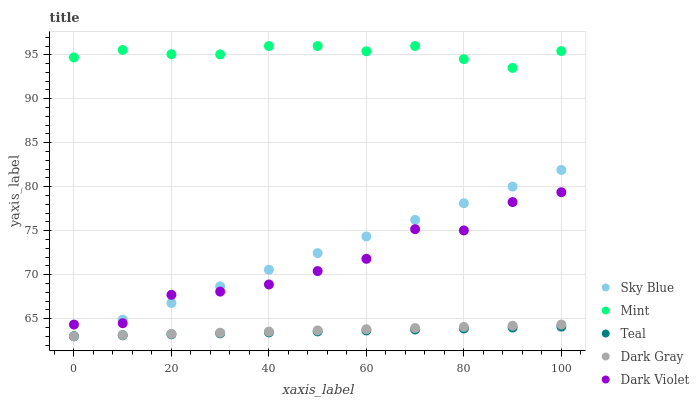Does Teal have the minimum area under the curve?
Answer yes or no. Yes. Does Mint have the maximum area under the curve?
Answer yes or no. Yes. Does Sky Blue have the minimum area under the curve?
Answer yes or no. No. Does Sky Blue have the maximum area under the curve?
Answer yes or no. No. Is Sky Blue the smoothest?
Answer yes or no. Yes. Is Dark Violet the roughest?
Answer yes or no. Yes. Is Mint the smoothest?
Answer yes or no. No. Is Mint the roughest?
Answer yes or no. No. Does Dark Gray have the lowest value?
Answer yes or no. Yes. Does Mint have the lowest value?
Answer yes or no. No. Does Mint have the highest value?
Answer yes or no. Yes. Does Sky Blue have the highest value?
Answer yes or no. No. Is Sky Blue less than Mint?
Answer yes or no. Yes. Is Mint greater than Dark Violet?
Answer yes or no. Yes. Does Dark Violet intersect Sky Blue?
Answer yes or no. Yes. Is Dark Violet less than Sky Blue?
Answer yes or no. No. Is Dark Violet greater than Sky Blue?
Answer yes or no. No. Does Sky Blue intersect Mint?
Answer yes or no. No. 